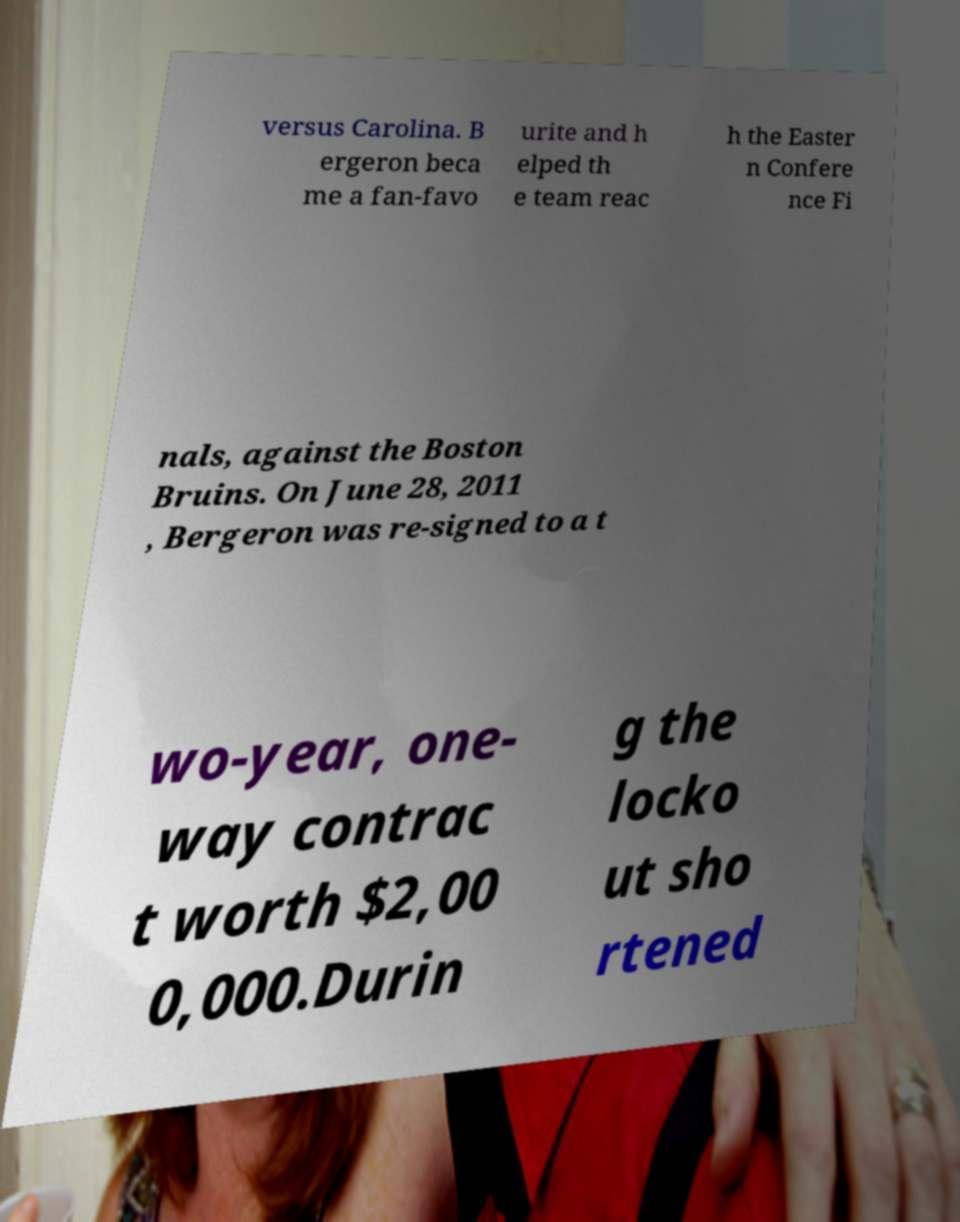Please read and relay the text visible in this image. What does it say? versus Carolina. B ergeron beca me a fan-favo urite and h elped th e team reac h the Easter n Confere nce Fi nals, against the Boston Bruins. On June 28, 2011 , Bergeron was re-signed to a t wo-year, one- way contrac t worth $2,00 0,000.Durin g the locko ut sho rtened 